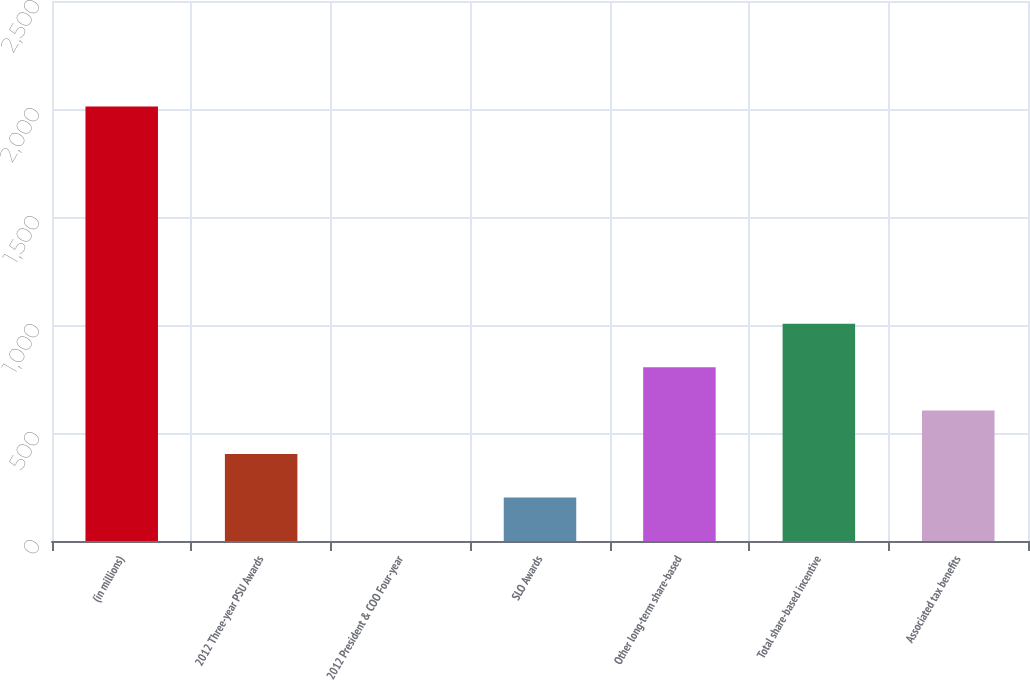Convert chart. <chart><loc_0><loc_0><loc_500><loc_500><bar_chart><fcel>(in millions)<fcel>2012 Three-year PSU Awards<fcel>2012 President & COO Four-year<fcel>SLO Awards<fcel>Other long-term share-based<fcel>Total share-based incentive<fcel>Associated tax benefits<nl><fcel>2012<fcel>402.56<fcel>0.2<fcel>201.38<fcel>804.92<fcel>1006.1<fcel>603.74<nl></chart> 